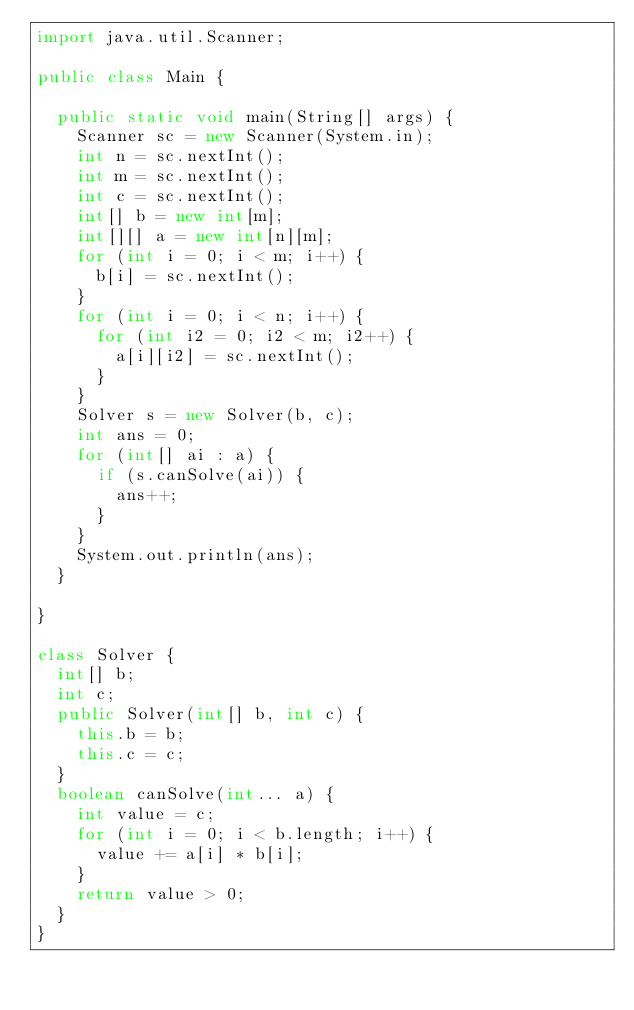Convert code to text. <code><loc_0><loc_0><loc_500><loc_500><_Java_>import java.util.Scanner;

public class Main {
	
	public static void main(String[] args) {
		Scanner sc = new Scanner(System.in);
		int n = sc.nextInt();
		int m = sc.nextInt();
		int c = sc.nextInt();
		int[] b = new int[m];
		int[][] a = new int[n][m];
		for (int i = 0; i < m; i++) {
			b[i] = sc.nextInt();
		}
		for (int i = 0; i < n; i++) {
			for (int i2 = 0; i2 < m; i2++) {
				a[i][i2] = sc.nextInt();
			}
		}
		Solver s = new Solver(b, c);
		int ans = 0;
		for (int[] ai : a) {
			if (s.canSolve(ai)) {
				ans++;
			}
		}
		System.out.println(ans);
	}
	
}

class Solver {
	int[] b;
	int c;
	public Solver(int[] b, int c) {
		this.b = b;
		this.c = c;
	}
	boolean canSolve(int... a) {
		int value = c;
		for (int i = 0; i < b.length; i++) {
			value += a[i] * b[i];
		}
		return value > 0;
	}
}
</code> 